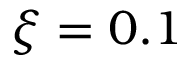Convert formula to latex. <formula><loc_0><loc_0><loc_500><loc_500>\xi = 0 . 1</formula> 